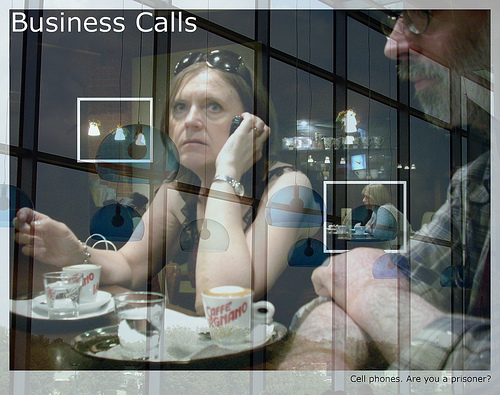Does the person to the left of the man wear a sweater? No, the person to the left of the man does not wear a sweater. 